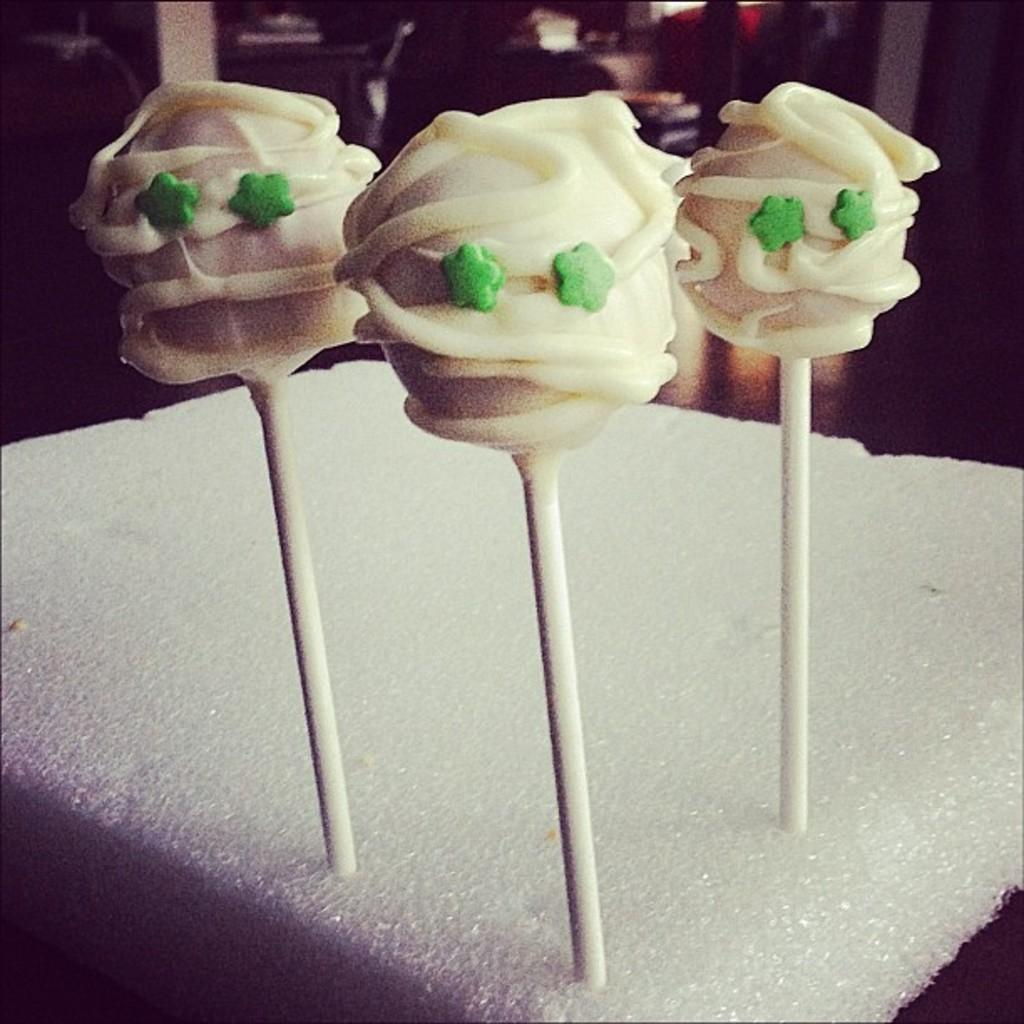How many sugar candies are visible in the image? There are three sugar candies in the image. What is the color of the surface on which the sugar candies are placed? The sugar candies are on a white surface. What type of pipe is connected to the kettle in the image? There is no pipe or kettle present in the image; it only features three sugar candies on a white surface. 